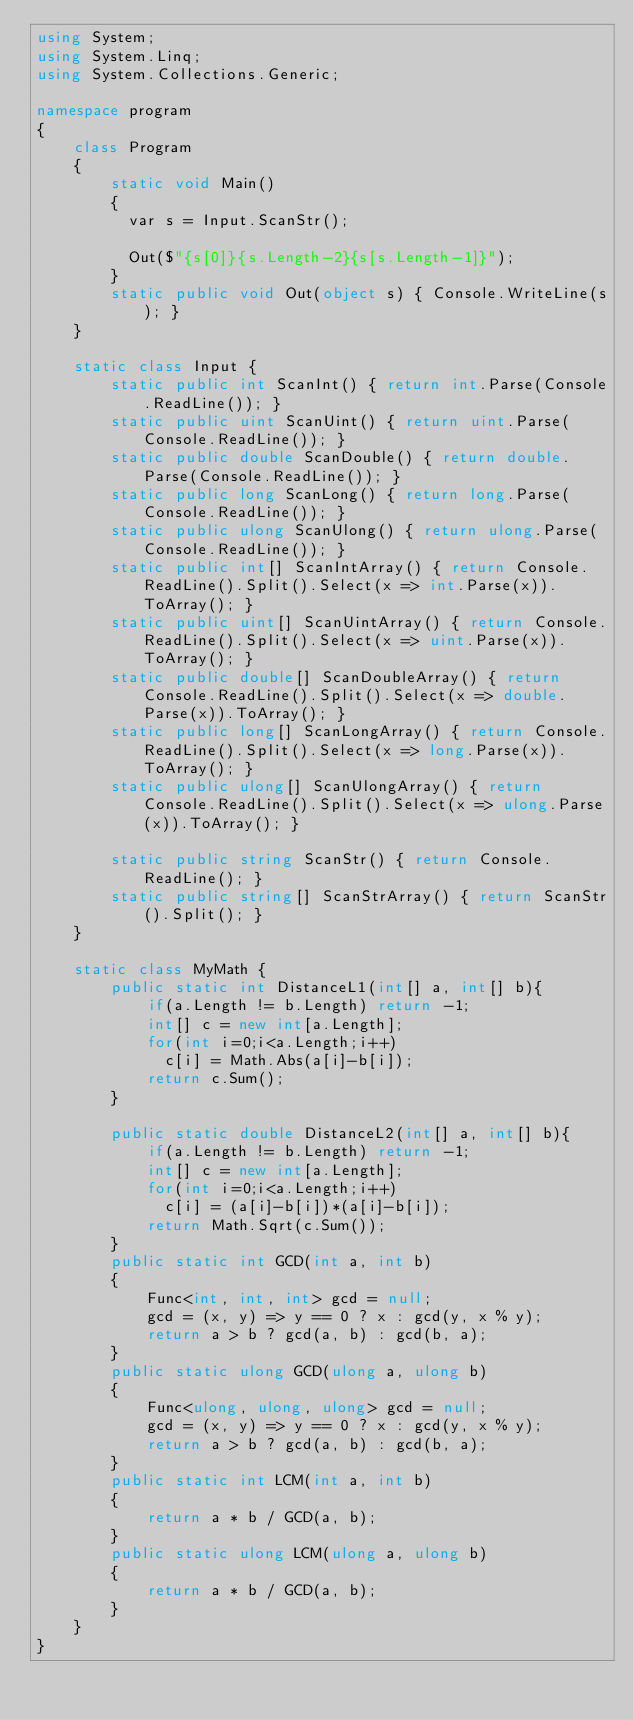Convert code to text. <code><loc_0><loc_0><loc_500><loc_500><_C#_>using System;
using System.Linq;
using System.Collections.Generic;

namespace program
{
    class Program
    {
        static void Main()
        {
          var s = Input.ScanStr();
          
          Out($"{s[0]}{s.Length-2}{s[s.Length-1]}");
        }
        static public void Out(object s) { Console.WriteLine(s); }
    }
    
    static class Input {
        static public int ScanInt() { return int.Parse(Console.ReadLine()); }
        static public uint ScanUint() { return uint.Parse(Console.ReadLine()); }
        static public double ScanDouble() { return double.Parse(Console.ReadLine()); }
        static public long ScanLong() { return long.Parse(Console.ReadLine()); }
        static public ulong ScanUlong() { return ulong.Parse(Console.ReadLine()); }
        static public int[] ScanIntArray() { return Console.ReadLine().Split().Select(x => int.Parse(x)).ToArray(); }
        static public uint[] ScanUintArray() { return Console.ReadLine().Split().Select(x => uint.Parse(x)).ToArray(); }
        static public double[] ScanDoubleArray() { return Console.ReadLine().Split().Select(x => double.Parse(x)).ToArray(); }
        static public long[] ScanLongArray() { return Console.ReadLine().Split().Select(x => long.Parse(x)).ToArray(); }
        static public ulong[] ScanUlongArray() { return Console.ReadLine().Split().Select(x => ulong.Parse(x)).ToArray(); }

        static public string ScanStr() { return Console.ReadLine(); }
        static public string[] ScanStrArray() { return ScanStr().Split(); }
    }

    static class MyMath {
        public static int DistanceL1(int[] a, int[] b){
            if(a.Length != b.Length) return -1;
            int[] c = new int[a.Length];
            for(int i=0;i<a.Length;i++)
              c[i] = Math.Abs(a[i]-b[i]);
            return c.Sum();
        }

        public static double DistanceL2(int[] a, int[] b){
            if(a.Length != b.Length) return -1;
            int[] c = new int[a.Length];
            for(int i=0;i<a.Length;i++)
              c[i] = (a[i]-b[i])*(a[i]-b[i]);
            return Math.Sqrt(c.Sum());
        }
        public static int GCD(int a, int b)
        {
            Func<int, int, int> gcd = null;
            gcd = (x, y) => y == 0 ? x : gcd(y, x % y);
            return a > b ? gcd(a, b) : gcd(b, a);
        }
        public static ulong GCD(ulong a, ulong b)
        {
            Func<ulong, ulong, ulong> gcd = null;
            gcd = (x, y) => y == 0 ? x : gcd(y, x % y);
            return a > b ? gcd(a, b) : gcd(b, a);
        }
        public static int LCM(int a, int b)
        {
            return a * b / GCD(a, b);
        }
        public static ulong LCM(ulong a, ulong b)
        {
            return a * b / GCD(a, b);
        }
    }
}
</code> 